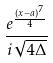Convert formula to latex. <formula><loc_0><loc_0><loc_500><loc_500>\frac { e ^ { \frac { ( x - a ) ^ { 7 } } { 4 } } } { i \sqrt { 4 \Delta } }</formula> 